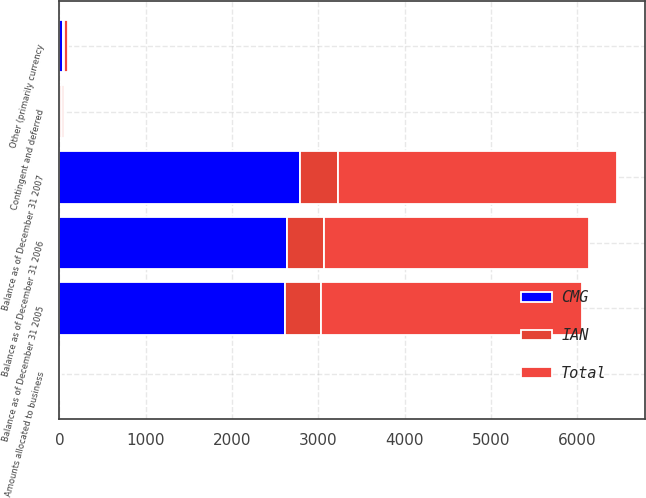<chart> <loc_0><loc_0><loc_500><loc_500><stacked_bar_chart><ecel><fcel>Balance as of December 31 2005<fcel>Contingent and deferred<fcel>Amounts allocated to business<fcel>Other (primarily currency<fcel>Balance as of December 31 2006<fcel>Balance as of December 31 2007<nl><fcel>CMG<fcel>2612.7<fcel>11.1<fcel>9.1<fcel>45<fcel>2632.5<fcel>2789.7<nl><fcel>IAN<fcel>418.2<fcel>13.2<fcel>2.7<fcel>6.6<fcel>435.3<fcel>441.9<nl><fcel>Total<fcel>3030.9<fcel>24.3<fcel>11.8<fcel>51.6<fcel>3067.8<fcel>3231.6<nl></chart> 